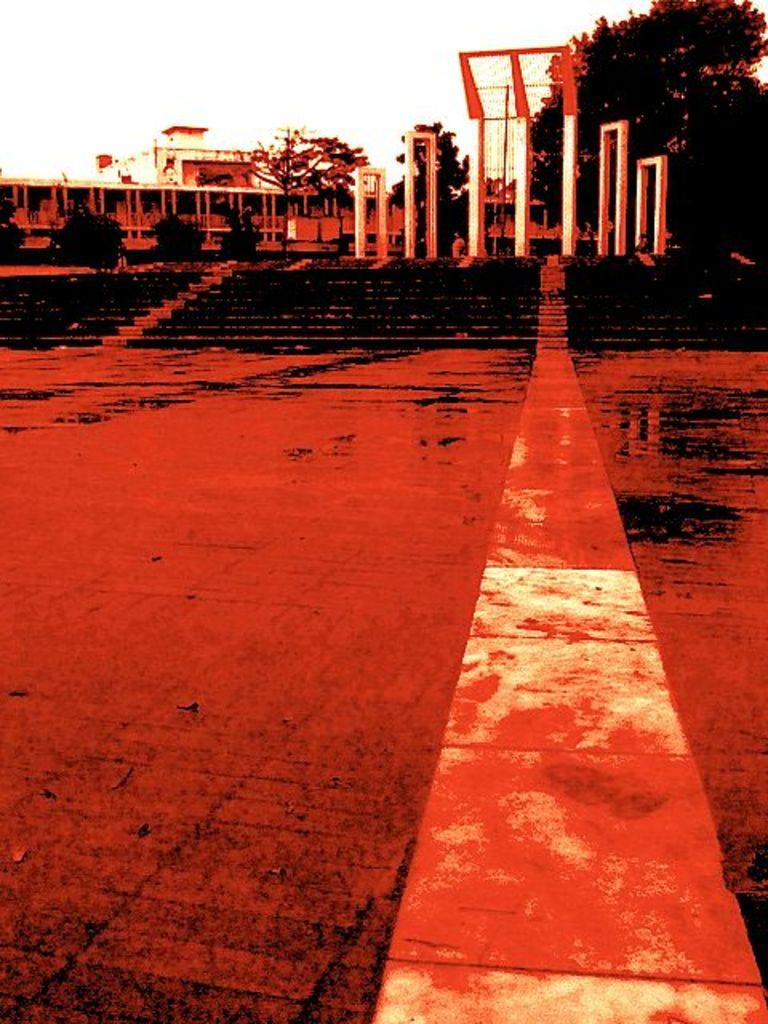What type of structures can be seen in the image? There are buildings in the image. What architectural feature is present in the image? There is a staircase in the image. What can be used for walking or traveling in the image? There is a pathway in the image. What type of vegetation is visible in the image? There are trees in the image. What is visible above the structures and vegetation in the image? The sky is visible in the image. Can you see the stranger's daughter playing with a hook in the image? There is no stranger or hook present in the image; it features buildings, a staircase, a pathway, trees, and the sky. 